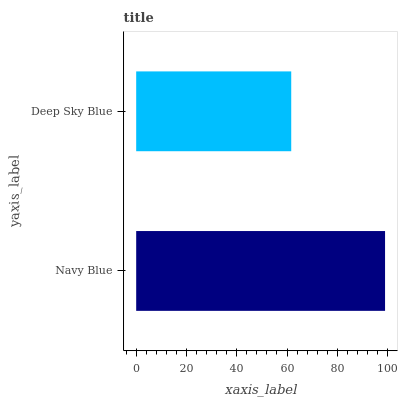Is Deep Sky Blue the minimum?
Answer yes or no. Yes. Is Navy Blue the maximum?
Answer yes or no. Yes. Is Deep Sky Blue the maximum?
Answer yes or no. No. Is Navy Blue greater than Deep Sky Blue?
Answer yes or no. Yes. Is Deep Sky Blue less than Navy Blue?
Answer yes or no. Yes. Is Deep Sky Blue greater than Navy Blue?
Answer yes or no. No. Is Navy Blue less than Deep Sky Blue?
Answer yes or no. No. Is Navy Blue the high median?
Answer yes or no. Yes. Is Deep Sky Blue the low median?
Answer yes or no. Yes. Is Deep Sky Blue the high median?
Answer yes or no. No. Is Navy Blue the low median?
Answer yes or no. No. 